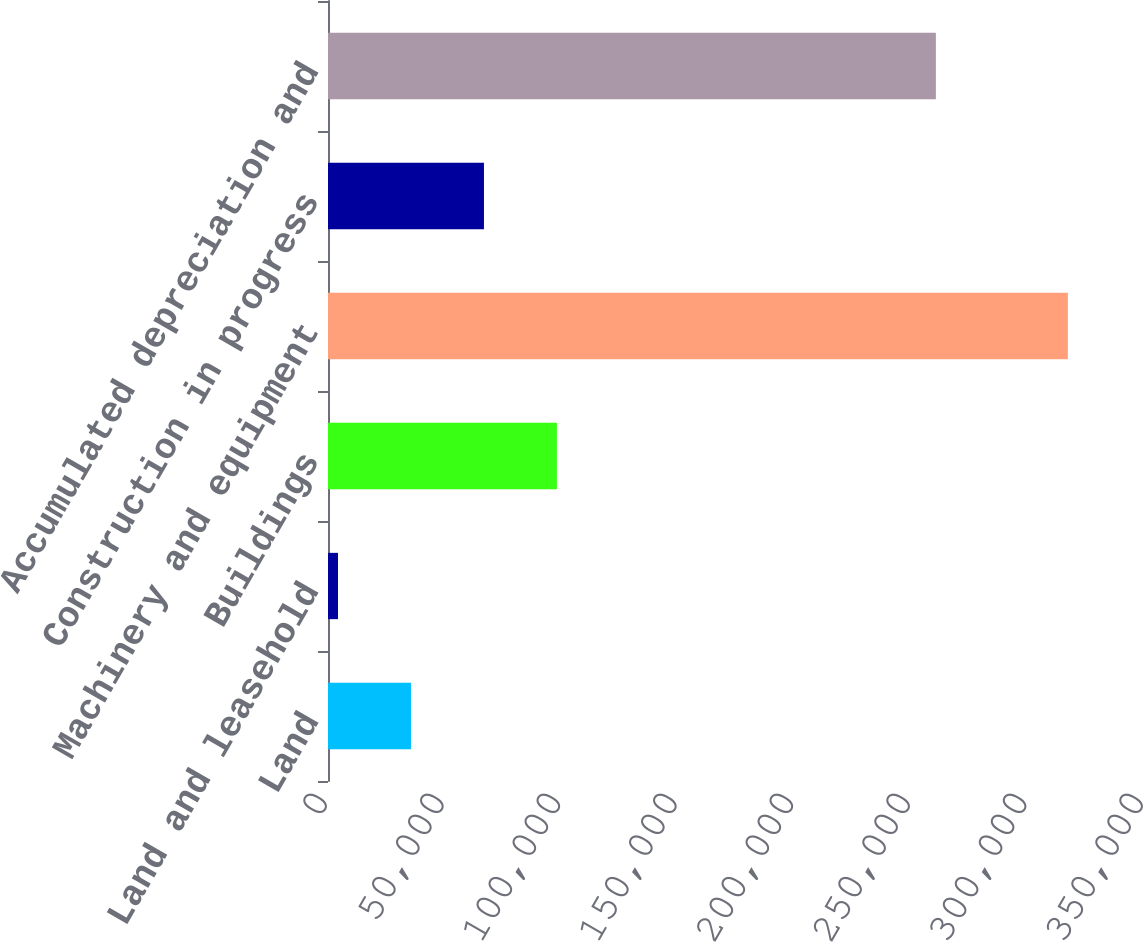Convert chart to OTSL. <chart><loc_0><loc_0><loc_500><loc_500><bar_chart><fcel>Land<fcel>Land and leasehold<fcel>Buildings<fcel>Machinery and equipment<fcel>Construction in progress<fcel>Accumulated depreciation and<nl><fcel>35589<fcel>4284<fcel>98199<fcel>317334<fcel>66894<fcel>260731<nl></chart> 